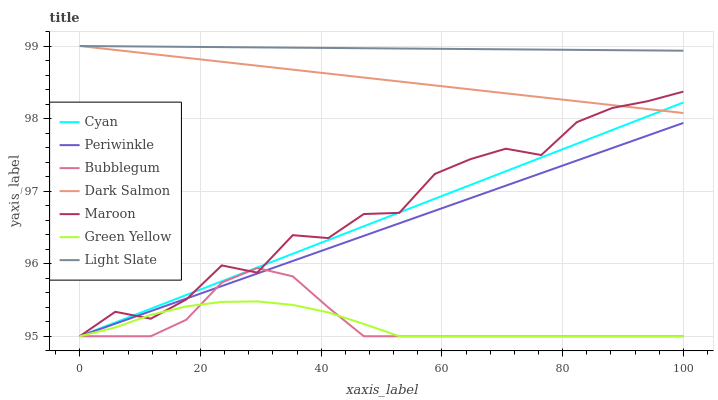Does Dark Salmon have the minimum area under the curve?
Answer yes or no. No. Does Dark Salmon have the maximum area under the curve?
Answer yes or no. No. Is Dark Salmon the smoothest?
Answer yes or no. No. Is Dark Salmon the roughest?
Answer yes or no. No. Does Dark Salmon have the lowest value?
Answer yes or no. No. Does Maroon have the highest value?
Answer yes or no. No. Is Bubblegum less than Dark Salmon?
Answer yes or no. Yes. Is Light Slate greater than Bubblegum?
Answer yes or no. Yes. Does Bubblegum intersect Dark Salmon?
Answer yes or no. No. 